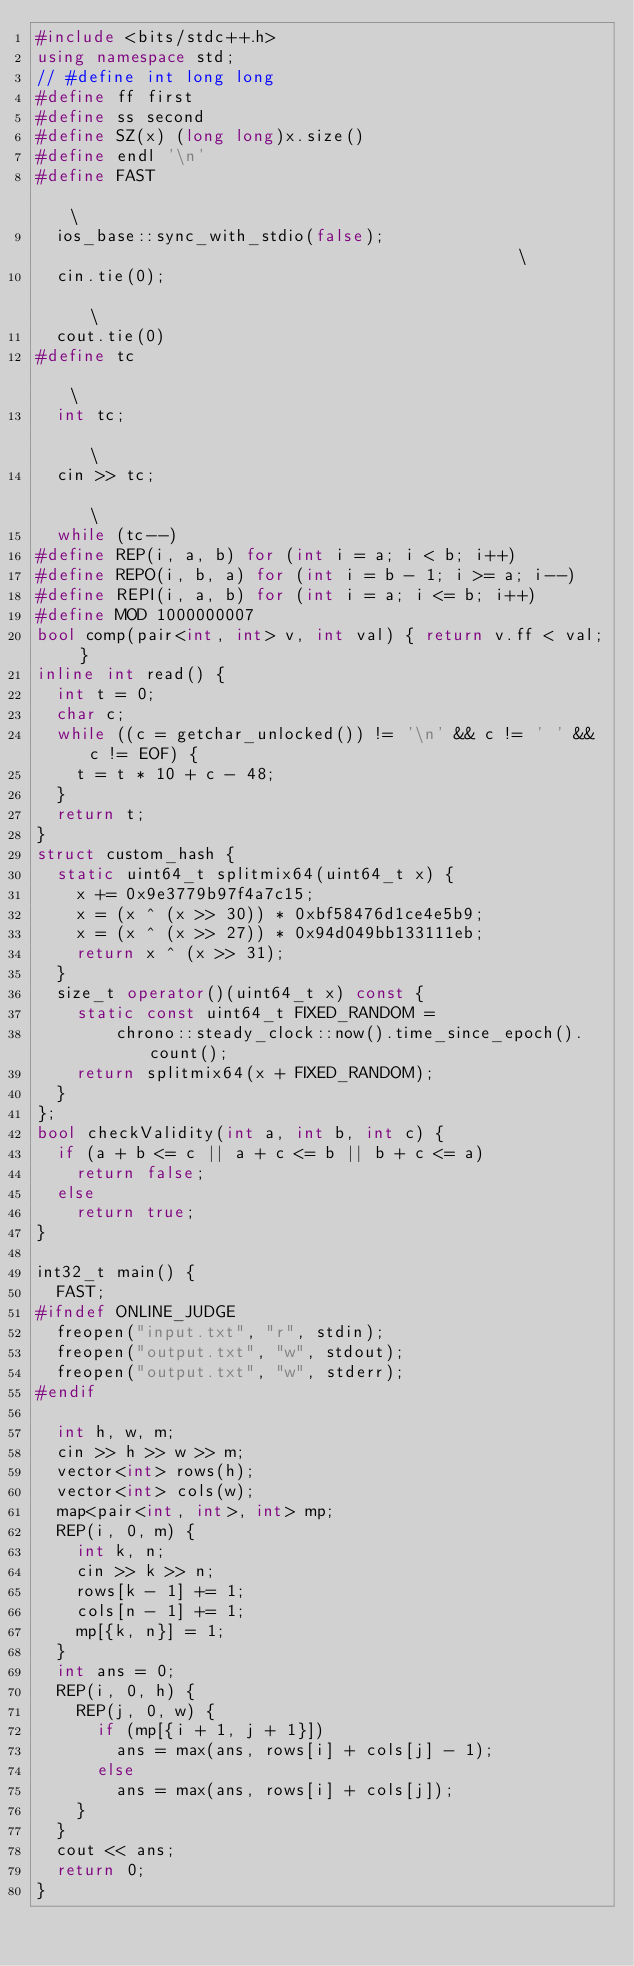<code> <loc_0><loc_0><loc_500><loc_500><_C++_>#include <bits/stdc++.h>
using namespace std;
// #define int long long
#define ff first
#define ss second
#define SZ(x) (long long)x.size()
#define endl '\n'
#define FAST                                                                   \
  ios_base::sync_with_stdio(false);                                            \
  cin.tie(0);                                                                  \
  cout.tie(0)
#define tc                                                                     \
  int tc;                                                                      \
  cin >> tc;                                                                   \
  while (tc--)
#define REP(i, a, b) for (int i = a; i < b; i++)
#define REPO(i, b, a) for (int i = b - 1; i >= a; i--)
#define REPI(i, a, b) for (int i = a; i <= b; i++)
#define MOD 1000000007
bool comp(pair<int, int> v, int val) { return v.ff < val; }
inline int read() {
  int t = 0;
  char c;
  while ((c = getchar_unlocked()) != '\n' && c != ' ' && c != EOF) {
    t = t * 10 + c - 48;
  }
  return t;
}
struct custom_hash {
  static uint64_t splitmix64(uint64_t x) {
    x += 0x9e3779b97f4a7c15;
    x = (x ^ (x >> 30)) * 0xbf58476d1ce4e5b9;
    x = (x ^ (x >> 27)) * 0x94d049bb133111eb;
    return x ^ (x >> 31);
  }
  size_t operator()(uint64_t x) const {
    static const uint64_t FIXED_RANDOM =
        chrono::steady_clock::now().time_since_epoch().count();
    return splitmix64(x + FIXED_RANDOM);
  }
};
bool checkValidity(int a, int b, int c) {
  if (a + b <= c || a + c <= b || b + c <= a)
    return false;
  else
    return true;
}

int32_t main() {
  FAST;
#ifndef ONLINE_JUDGE
  freopen("input.txt", "r", stdin);
  freopen("output.txt", "w", stdout);
  freopen("output.txt", "w", stderr);
#endif

  int h, w, m;
  cin >> h >> w >> m;
  vector<int> rows(h);
  vector<int> cols(w);
  map<pair<int, int>, int> mp;
  REP(i, 0, m) {
    int k, n;
    cin >> k >> n;
    rows[k - 1] += 1;
    cols[n - 1] += 1;
    mp[{k, n}] = 1;
  }
  int ans = 0;
  REP(i, 0, h) {
    REP(j, 0, w) {
      if (mp[{i + 1, j + 1}])
        ans = max(ans, rows[i] + cols[j] - 1);
      else
        ans = max(ans, rows[i] + cols[j]);
    }
  }
  cout << ans;
  return 0;
}
</code> 